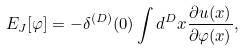<formula> <loc_0><loc_0><loc_500><loc_500>E _ { J } [ \varphi ] = - \delta ^ { ( D ) } ( 0 ) \int d ^ { D } x \frac { \partial u ( x ) } { \partial \varphi ( x ) } ,</formula> 